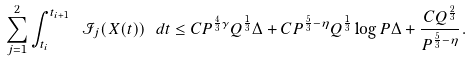Convert formula to latex. <formula><loc_0><loc_0><loc_500><loc_500>\sum _ { j = 1 } ^ { 2 } \int _ { t _ { i } } ^ { t _ { i + 1 } } \ { \mathcal { I } } _ { j } ( X ( t ) ) \ d t \leq C P ^ { \frac { 4 } { 3 } \gamma } Q ^ { \frac { 1 } { 3 } } \Delta + C P ^ { \frac { 5 } { 3 } - \eta } Q ^ { \frac { 1 } { 3 } } \log P \Delta + \frac { C Q ^ { \frac { 2 } { 3 } } } { P ^ { \frac { 5 } { 3 } - \eta } } .</formula> 